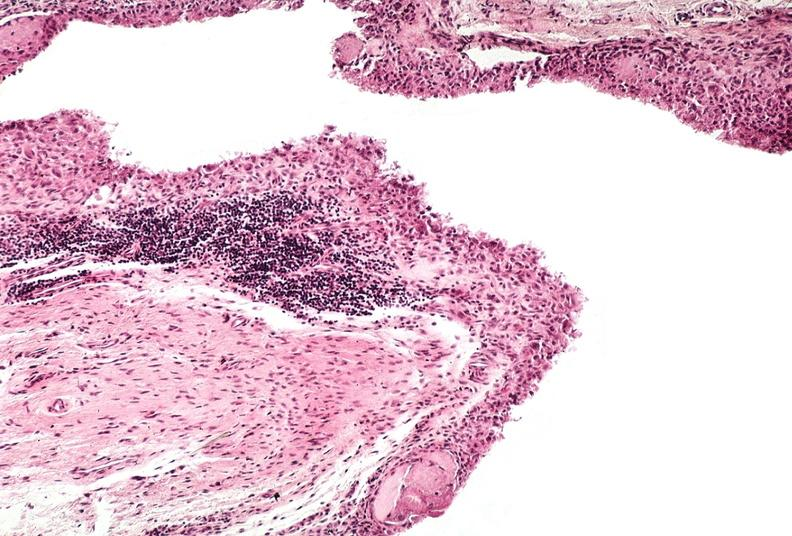s hearts present?
Answer the question using a single word or phrase. No 